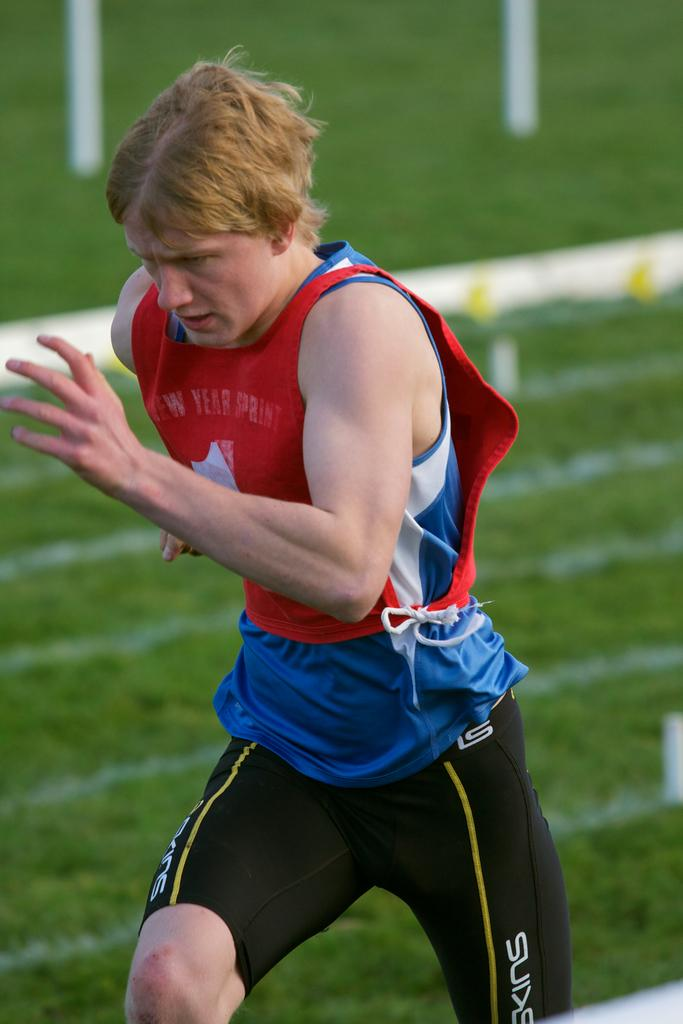Provide a one-sentence caption for the provided image. A sprinter has the word "year" on his red tank top as he runs. 